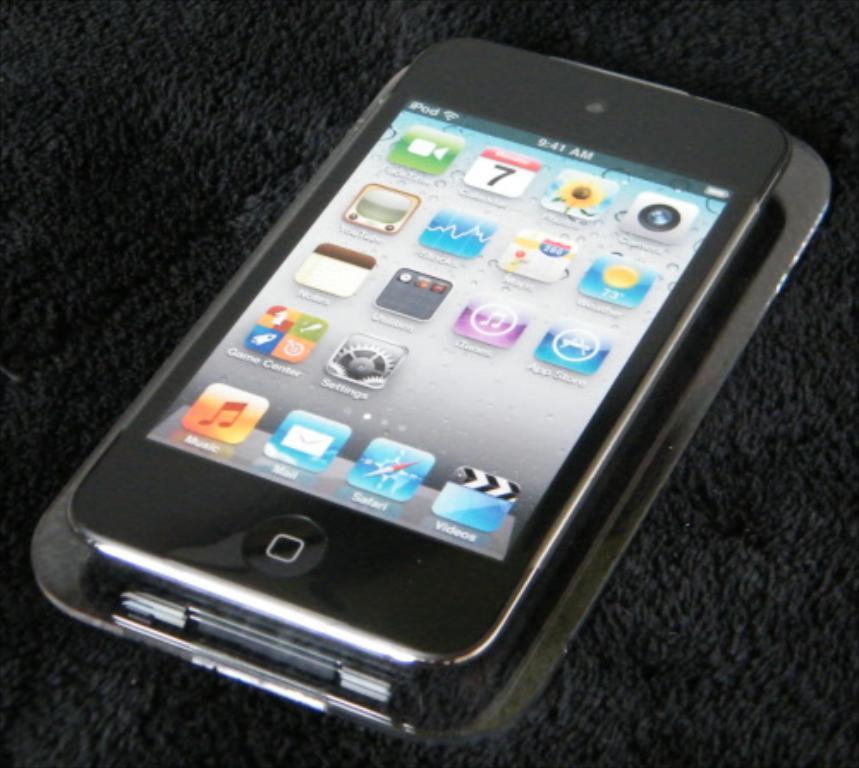What time is displayed on the device?
Give a very brief answer. 9:41 am. 